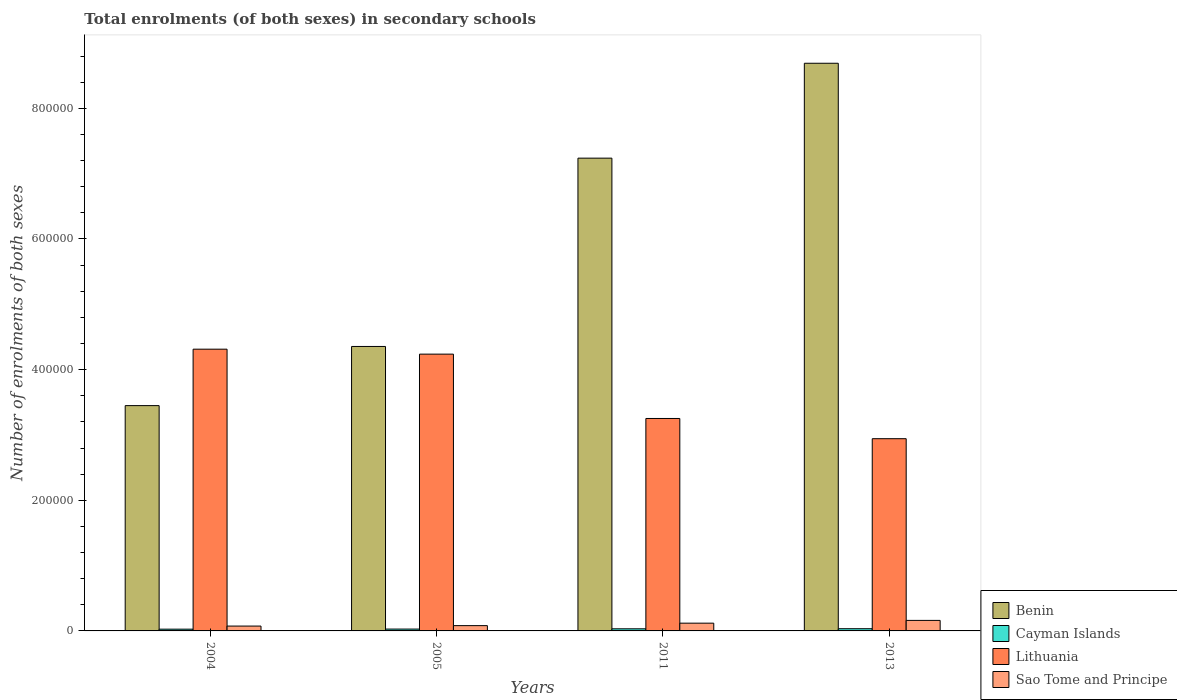Are the number of bars on each tick of the X-axis equal?
Provide a succinct answer. Yes. How many bars are there on the 4th tick from the left?
Ensure brevity in your answer.  4. In how many cases, is the number of bars for a given year not equal to the number of legend labels?
Your answer should be very brief. 0. What is the number of enrolments in secondary schools in Lithuania in 2013?
Ensure brevity in your answer.  2.94e+05. Across all years, what is the maximum number of enrolments in secondary schools in Benin?
Offer a very short reply. 8.69e+05. Across all years, what is the minimum number of enrolments in secondary schools in Cayman Islands?
Ensure brevity in your answer.  2701. In which year was the number of enrolments in secondary schools in Benin maximum?
Your answer should be very brief. 2013. What is the total number of enrolments in secondary schools in Cayman Islands in the graph?
Your answer should be very brief. 1.22e+04. What is the difference between the number of enrolments in secondary schools in Lithuania in 2011 and that in 2013?
Keep it short and to the point. 3.09e+04. What is the difference between the number of enrolments in secondary schools in Cayman Islands in 2011 and the number of enrolments in secondary schools in Lithuania in 2004?
Ensure brevity in your answer.  -4.28e+05. What is the average number of enrolments in secondary schools in Lithuania per year?
Make the answer very short. 3.69e+05. In the year 2013, what is the difference between the number of enrolments in secondary schools in Sao Tome and Principe and number of enrolments in secondary schools in Benin?
Your answer should be very brief. -8.53e+05. In how many years, is the number of enrolments in secondary schools in Benin greater than 40000?
Keep it short and to the point. 4. What is the ratio of the number of enrolments in secondary schools in Lithuania in 2011 to that in 2013?
Provide a short and direct response. 1.11. Is the number of enrolments in secondary schools in Cayman Islands in 2011 less than that in 2013?
Your answer should be compact. Yes. Is the difference between the number of enrolments in secondary schools in Sao Tome and Principe in 2004 and 2013 greater than the difference between the number of enrolments in secondary schools in Benin in 2004 and 2013?
Offer a very short reply. Yes. What is the difference between the highest and the second highest number of enrolments in secondary schools in Cayman Islands?
Give a very brief answer. 141. What is the difference between the highest and the lowest number of enrolments in secondary schools in Lithuania?
Keep it short and to the point. 1.37e+05. In how many years, is the number of enrolments in secondary schools in Sao Tome and Principe greater than the average number of enrolments in secondary schools in Sao Tome and Principe taken over all years?
Your answer should be compact. 2. Is the sum of the number of enrolments in secondary schools in Lithuania in 2004 and 2013 greater than the maximum number of enrolments in secondary schools in Cayman Islands across all years?
Make the answer very short. Yes. Is it the case that in every year, the sum of the number of enrolments in secondary schools in Benin and number of enrolments in secondary schools in Sao Tome and Principe is greater than the sum of number of enrolments in secondary schools in Cayman Islands and number of enrolments in secondary schools in Lithuania?
Your answer should be very brief. No. What does the 4th bar from the left in 2013 represents?
Offer a terse response. Sao Tome and Principe. What does the 4th bar from the right in 2011 represents?
Give a very brief answer. Benin. How many bars are there?
Give a very brief answer. 16. How many years are there in the graph?
Your answer should be compact. 4. How many legend labels are there?
Your answer should be very brief. 4. How are the legend labels stacked?
Provide a short and direct response. Vertical. What is the title of the graph?
Your answer should be compact. Total enrolments (of both sexes) in secondary schools. What is the label or title of the X-axis?
Keep it short and to the point. Years. What is the label or title of the Y-axis?
Offer a terse response. Number of enrolments of both sexes. What is the Number of enrolments of both sexes of Benin in 2004?
Offer a very short reply. 3.45e+05. What is the Number of enrolments of both sexes of Cayman Islands in 2004?
Give a very brief answer. 2701. What is the Number of enrolments of both sexes of Lithuania in 2004?
Give a very brief answer. 4.31e+05. What is the Number of enrolments of both sexes in Sao Tome and Principe in 2004?
Give a very brief answer. 7423. What is the Number of enrolments of both sexes of Benin in 2005?
Provide a short and direct response. 4.35e+05. What is the Number of enrolments of both sexes of Cayman Islands in 2005?
Your response must be concise. 2824. What is the Number of enrolments of both sexes of Lithuania in 2005?
Your response must be concise. 4.24e+05. What is the Number of enrolments of both sexes of Sao Tome and Principe in 2005?
Give a very brief answer. 8091. What is the Number of enrolments of both sexes in Benin in 2011?
Your answer should be very brief. 7.24e+05. What is the Number of enrolments of both sexes of Cayman Islands in 2011?
Your answer should be compact. 3246. What is the Number of enrolments of both sexes in Lithuania in 2011?
Give a very brief answer. 3.25e+05. What is the Number of enrolments of both sexes in Sao Tome and Principe in 2011?
Give a very brief answer. 1.19e+04. What is the Number of enrolments of both sexes of Benin in 2013?
Give a very brief answer. 8.69e+05. What is the Number of enrolments of both sexes of Cayman Islands in 2013?
Offer a terse response. 3387. What is the Number of enrolments of both sexes in Lithuania in 2013?
Your response must be concise. 2.94e+05. What is the Number of enrolments of both sexes in Sao Tome and Principe in 2013?
Give a very brief answer. 1.61e+04. Across all years, what is the maximum Number of enrolments of both sexes of Benin?
Keep it short and to the point. 8.69e+05. Across all years, what is the maximum Number of enrolments of both sexes of Cayman Islands?
Give a very brief answer. 3387. Across all years, what is the maximum Number of enrolments of both sexes of Lithuania?
Offer a very short reply. 4.31e+05. Across all years, what is the maximum Number of enrolments of both sexes of Sao Tome and Principe?
Your answer should be very brief. 1.61e+04. Across all years, what is the minimum Number of enrolments of both sexes in Benin?
Your answer should be compact. 3.45e+05. Across all years, what is the minimum Number of enrolments of both sexes in Cayman Islands?
Make the answer very short. 2701. Across all years, what is the minimum Number of enrolments of both sexes of Lithuania?
Your answer should be very brief. 2.94e+05. Across all years, what is the minimum Number of enrolments of both sexes in Sao Tome and Principe?
Provide a short and direct response. 7423. What is the total Number of enrolments of both sexes of Benin in the graph?
Provide a succinct answer. 2.37e+06. What is the total Number of enrolments of both sexes in Cayman Islands in the graph?
Offer a terse response. 1.22e+04. What is the total Number of enrolments of both sexes in Lithuania in the graph?
Your answer should be very brief. 1.47e+06. What is the total Number of enrolments of both sexes in Sao Tome and Principe in the graph?
Your response must be concise. 4.35e+04. What is the difference between the Number of enrolments of both sexes in Benin in 2004 and that in 2005?
Your response must be concise. -9.06e+04. What is the difference between the Number of enrolments of both sexes in Cayman Islands in 2004 and that in 2005?
Keep it short and to the point. -123. What is the difference between the Number of enrolments of both sexes of Lithuania in 2004 and that in 2005?
Make the answer very short. 7597. What is the difference between the Number of enrolments of both sexes in Sao Tome and Principe in 2004 and that in 2005?
Make the answer very short. -668. What is the difference between the Number of enrolments of both sexes in Benin in 2004 and that in 2011?
Your response must be concise. -3.79e+05. What is the difference between the Number of enrolments of both sexes of Cayman Islands in 2004 and that in 2011?
Your answer should be compact. -545. What is the difference between the Number of enrolments of both sexes of Lithuania in 2004 and that in 2011?
Your response must be concise. 1.06e+05. What is the difference between the Number of enrolments of both sexes in Sao Tome and Principe in 2004 and that in 2011?
Provide a succinct answer. -4461. What is the difference between the Number of enrolments of both sexes in Benin in 2004 and that in 2013?
Keep it short and to the point. -5.24e+05. What is the difference between the Number of enrolments of both sexes in Cayman Islands in 2004 and that in 2013?
Provide a succinct answer. -686. What is the difference between the Number of enrolments of both sexes in Lithuania in 2004 and that in 2013?
Keep it short and to the point. 1.37e+05. What is the difference between the Number of enrolments of both sexes of Sao Tome and Principe in 2004 and that in 2013?
Offer a very short reply. -8695. What is the difference between the Number of enrolments of both sexes in Benin in 2005 and that in 2011?
Your response must be concise. -2.88e+05. What is the difference between the Number of enrolments of both sexes of Cayman Islands in 2005 and that in 2011?
Provide a succinct answer. -422. What is the difference between the Number of enrolments of both sexes of Lithuania in 2005 and that in 2011?
Provide a short and direct response. 9.85e+04. What is the difference between the Number of enrolments of both sexes of Sao Tome and Principe in 2005 and that in 2011?
Make the answer very short. -3793. What is the difference between the Number of enrolments of both sexes in Benin in 2005 and that in 2013?
Ensure brevity in your answer.  -4.34e+05. What is the difference between the Number of enrolments of both sexes of Cayman Islands in 2005 and that in 2013?
Offer a very short reply. -563. What is the difference between the Number of enrolments of both sexes of Lithuania in 2005 and that in 2013?
Ensure brevity in your answer.  1.29e+05. What is the difference between the Number of enrolments of both sexes in Sao Tome and Principe in 2005 and that in 2013?
Your answer should be compact. -8027. What is the difference between the Number of enrolments of both sexes of Benin in 2011 and that in 2013?
Keep it short and to the point. -1.45e+05. What is the difference between the Number of enrolments of both sexes of Cayman Islands in 2011 and that in 2013?
Give a very brief answer. -141. What is the difference between the Number of enrolments of both sexes of Lithuania in 2011 and that in 2013?
Provide a succinct answer. 3.09e+04. What is the difference between the Number of enrolments of both sexes of Sao Tome and Principe in 2011 and that in 2013?
Give a very brief answer. -4234. What is the difference between the Number of enrolments of both sexes in Benin in 2004 and the Number of enrolments of both sexes in Cayman Islands in 2005?
Your answer should be very brief. 3.42e+05. What is the difference between the Number of enrolments of both sexes of Benin in 2004 and the Number of enrolments of both sexes of Lithuania in 2005?
Your response must be concise. -7.88e+04. What is the difference between the Number of enrolments of both sexes in Benin in 2004 and the Number of enrolments of both sexes in Sao Tome and Principe in 2005?
Make the answer very short. 3.37e+05. What is the difference between the Number of enrolments of both sexes of Cayman Islands in 2004 and the Number of enrolments of both sexes of Lithuania in 2005?
Provide a short and direct response. -4.21e+05. What is the difference between the Number of enrolments of both sexes of Cayman Islands in 2004 and the Number of enrolments of both sexes of Sao Tome and Principe in 2005?
Your response must be concise. -5390. What is the difference between the Number of enrolments of both sexes of Lithuania in 2004 and the Number of enrolments of both sexes of Sao Tome and Principe in 2005?
Your answer should be very brief. 4.23e+05. What is the difference between the Number of enrolments of both sexes in Benin in 2004 and the Number of enrolments of both sexes in Cayman Islands in 2011?
Keep it short and to the point. 3.42e+05. What is the difference between the Number of enrolments of both sexes in Benin in 2004 and the Number of enrolments of both sexes in Lithuania in 2011?
Provide a succinct answer. 1.97e+04. What is the difference between the Number of enrolments of both sexes of Benin in 2004 and the Number of enrolments of both sexes of Sao Tome and Principe in 2011?
Ensure brevity in your answer.  3.33e+05. What is the difference between the Number of enrolments of both sexes in Cayman Islands in 2004 and the Number of enrolments of both sexes in Lithuania in 2011?
Provide a succinct answer. -3.23e+05. What is the difference between the Number of enrolments of both sexes in Cayman Islands in 2004 and the Number of enrolments of both sexes in Sao Tome and Principe in 2011?
Provide a short and direct response. -9183. What is the difference between the Number of enrolments of both sexes in Lithuania in 2004 and the Number of enrolments of both sexes in Sao Tome and Principe in 2011?
Your answer should be very brief. 4.19e+05. What is the difference between the Number of enrolments of both sexes in Benin in 2004 and the Number of enrolments of both sexes in Cayman Islands in 2013?
Provide a short and direct response. 3.42e+05. What is the difference between the Number of enrolments of both sexes of Benin in 2004 and the Number of enrolments of both sexes of Lithuania in 2013?
Make the answer very short. 5.06e+04. What is the difference between the Number of enrolments of both sexes of Benin in 2004 and the Number of enrolments of both sexes of Sao Tome and Principe in 2013?
Your answer should be very brief. 3.29e+05. What is the difference between the Number of enrolments of both sexes in Cayman Islands in 2004 and the Number of enrolments of both sexes in Lithuania in 2013?
Your answer should be compact. -2.92e+05. What is the difference between the Number of enrolments of both sexes in Cayman Islands in 2004 and the Number of enrolments of both sexes in Sao Tome and Principe in 2013?
Offer a terse response. -1.34e+04. What is the difference between the Number of enrolments of both sexes in Lithuania in 2004 and the Number of enrolments of both sexes in Sao Tome and Principe in 2013?
Provide a succinct answer. 4.15e+05. What is the difference between the Number of enrolments of both sexes in Benin in 2005 and the Number of enrolments of both sexes in Cayman Islands in 2011?
Ensure brevity in your answer.  4.32e+05. What is the difference between the Number of enrolments of both sexes in Benin in 2005 and the Number of enrolments of both sexes in Lithuania in 2011?
Make the answer very short. 1.10e+05. What is the difference between the Number of enrolments of both sexes in Benin in 2005 and the Number of enrolments of both sexes in Sao Tome and Principe in 2011?
Your answer should be compact. 4.24e+05. What is the difference between the Number of enrolments of both sexes in Cayman Islands in 2005 and the Number of enrolments of both sexes in Lithuania in 2011?
Keep it short and to the point. -3.22e+05. What is the difference between the Number of enrolments of both sexes in Cayman Islands in 2005 and the Number of enrolments of both sexes in Sao Tome and Principe in 2011?
Your answer should be very brief. -9060. What is the difference between the Number of enrolments of both sexes in Lithuania in 2005 and the Number of enrolments of both sexes in Sao Tome and Principe in 2011?
Give a very brief answer. 4.12e+05. What is the difference between the Number of enrolments of both sexes of Benin in 2005 and the Number of enrolments of both sexes of Cayman Islands in 2013?
Keep it short and to the point. 4.32e+05. What is the difference between the Number of enrolments of both sexes of Benin in 2005 and the Number of enrolments of both sexes of Lithuania in 2013?
Your response must be concise. 1.41e+05. What is the difference between the Number of enrolments of both sexes of Benin in 2005 and the Number of enrolments of both sexes of Sao Tome and Principe in 2013?
Give a very brief answer. 4.19e+05. What is the difference between the Number of enrolments of both sexes of Cayman Islands in 2005 and the Number of enrolments of both sexes of Lithuania in 2013?
Your answer should be very brief. -2.91e+05. What is the difference between the Number of enrolments of both sexes in Cayman Islands in 2005 and the Number of enrolments of both sexes in Sao Tome and Principe in 2013?
Provide a short and direct response. -1.33e+04. What is the difference between the Number of enrolments of both sexes in Lithuania in 2005 and the Number of enrolments of both sexes in Sao Tome and Principe in 2013?
Offer a terse response. 4.08e+05. What is the difference between the Number of enrolments of both sexes in Benin in 2011 and the Number of enrolments of both sexes in Cayman Islands in 2013?
Keep it short and to the point. 7.20e+05. What is the difference between the Number of enrolments of both sexes in Benin in 2011 and the Number of enrolments of both sexes in Lithuania in 2013?
Your response must be concise. 4.29e+05. What is the difference between the Number of enrolments of both sexes in Benin in 2011 and the Number of enrolments of both sexes in Sao Tome and Principe in 2013?
Your response must be concise. 7.08e+05. What is the difference between the Number of enrolments of both sexes in Cayman Islands in 2011 and the Number of enrolments of both sexes in Lithuania in 2013?
Offer a very short reply. -2.91e+05. What is the difference between the Number of enrolments of both sexes in Cayman Islands in 2011 and the Number of enrolments of both sexes in Sao Tome and Principe in 2013?
Your answer should be very brief. -1.29e+04. What is the difference between the Number of enrolments of both sexes in Lithuania in 2011 and the Number of enrolments of both sexes in Sao Tome and Principe in 2013?
Make the answer very short. 3.09e+05. What is the average Number of enrolments of both sexes in Benin per year?
Provide a short and direct response. 5.93e+05. What is the average Number of enrolments of both sexes in Cayman Islands per year?
Ensure brevity in your answer.  3039.5. What is the average Number of enrolments of both sexes of Lithuania per year?
Offer a very short reply. 3.69e+05. What is the average Number of enrolments of both sexes in Sao Tome and Principe per year?
Your answer should be compact. 1.09e+04. In the year 2004, what is the difference between the Number of enrolments of both sexes in Benin and Number of enrolments of both sexes in Cayman Islands?
Give a very brief answer. 3.42e+05. In the year 2004, what is the difference between the Number of enrolments of both sexes of Benin and Number of enrolments of both sexes of Lithuania?
Offer a very short reply. -8.64e+04. In the year 2004, what is the difference between the Number of enrolments of both sexes in Benin and Number of enrolments of both sexes in Sao Tome and Principe?
Make the answer very short. 3.37e+05. In the year 2004, what is the difference between the Number of enrolments of both sexes of Cayman Islands and Number of enrolments of both sexes of Lithuania?
Give a very brief answer. -4.29e+05. In the year 2004, what is the difference between the Number of enrolments of both sexes of Cayman Islands and Number of enrolments of both sexes of Sao Tome and Principe?
Give a very brief answer. -4722. In the year 2004, what is the difference between the Number of enrolments of both sexes of Lithuania and Number of enrolments of both sexes of Sao Tome and Principe?
Make the answer very short. 4.24e+05. In the year 2005, what is the difference between the Number of enrolments of both sexes in Benin and Number of enrolments of both sexes in Cayman Islands?
Offer a very short reply. 4.33e+05. In the year 2005, what is the difference between the Number of enrolments of both sexes of Benin and Number of enrolments of both sexes of Lithuania?
Offer a very short reply. 1.17e+04. In the year 2005, what is the difference between the Number of enrolments of both sexes in Benin and Number of enrolments of both sexes in Sao Tome and Principe?
Your answer should be very brief. 4.27e+05. In the year 2005, what is the difference between the Number of enrolments of both sexes of Cayman Islands and Number of enrolments of both sexes of Lithuania?
Provide a succinct answer. -4.21e+05. In the year 2005, what is the difference between the Number of enrolments of both sexes in Cayman Islands and Number of enrolments of both sexes in Sao Tome and Principe?
Provide a short and direct response. -5267. In the year 2005, what is the difference between the Number of enrolments of both sexes in Lithuania and Number of enrolments of both sexes in Sao Tome and Principe?
Your answer should be very brief. 4.16e+05. In the year 2011, what is the difference between the Number of enrolments of both sexes in Benin and Number of enrolments of both sexes in Cayman Islands?
Your response must be concise. 7.20e+05. In the year 2011, what is the difference between the Number of enrolments of both sexes of Benin and Number of enrolments of both sexes of Lithuania?
Provide a succinct answer. 3.99e+05. In the year 2011, what is the difference between the Number of enrolments of both sexes in Benin and Number of enrolments of both sexes in Sao Tome and Principe?
Offer a terse response. 7.12e+05. In the year 2011, what is the difference between the Number of enrolments of both sexes in Cayman Islands and Number of enrolments of both sexes in Lithuania?
Ensure brevity in your answer.  -3.22e+05. In the year 2011, what is the difference between the Number of enrolments of both sexes in Cayman Islands and Number of enrolments of both sexes in Sao Tome and Principe?
Ensure brevity in your answer.  -8638. In the year 2011, what is the difference between the Number of enrolments of both sexes in Lithuania and Number of enrolments of both sexes in Sao Tome and Principe?
Provide a succinct answer. 3.13e+05. In the year 2013, what is the difference between the Number of enrolments of both sexes of Benin and Number of enrolments of both sexes of Cayman Islands?
Your answer should be very brief. 8.66e+05. In the year 2013, what is the difference between the Number of enrolments of both sexes of Benin and Number of enrolments of both sexes of Lithuania?
Offer a terse response. 5.75e+05. In the year 2013, what is the difference between the Number of enrolments of both sexes in Benin and Number of enrolments of both sexes in Sao Tome and Principe?
Your response must be concise. 8.53e+05. In the year 2013, what is the difference between the Number of enrolments of both sexes of Cayman Islands and Number of enrolments of both sexes of Lithuania?
Give a very brief answer. -2.91e+05. In the year 2013, what is the difference between the Number of enrolments of both sexes in Cayman Islands and Number of enrolments of both sexes in Sao Tome and Principe?
Provide a succinct answer. -1.27e+04. In the year 2013, what is the difference between the Number of enrolments of both sexes of Lithuania and Number of enrolments of both sexes of Sao Tome and Principe?
Provide a short and direct response. 2.78e+05. What is the ratio of the Number of enrolments of both sexes of Benin in 2004 to that in 2005?
Your response must be concise. 0.79. What is the ratio of the Number of enrolments of both sexes in Cayman Islands in 2004 to that in 2005?
Make the answer very short. 0.96. What is the ratio of the Number of enrolments of both sexes in Lithuania in 2004 to that in 2005?
Your answer should be compact. 1.02. What is the ratio of the Number of enrolments of both sexes in Sao Tome and Principe in 2004 to that in 2005?
Provide a short and direct response. 0.92. What is the ratio of the Number of enrolments of both sexes of Benin in 2004 to that in 2011?
Keep it short and to the point. 0.48. What is the ratio of the Number of enrolments of both sexes in Cayman Islands in 2004 to that in 2011?
Keep it short and to the point. 0.83. What is the ratio of the Number of enrolments of both sexes in Lithuania in 2004 to that in 2011?
Your response must be concise. 1.33. What is the ratio of the Number of enrolments of both sexes of Sao Tome and Principe in 2004 to that in 2011?
Ensure brevity in your answer.  0.62. What is the ratio of the Number of enrolments of both sexes of Benin in 2004 to that in 2013?
Give a very brief answer. 0.4. What is the ratio of the Number of enrolments of both sexes of Cayman Islands in 2004 to that in 2013?
Your response must be concise. 0.8. What is the ratio of the Number of enrolments of both sexes in Lithuania in 2004 to that in 2013?
Ensure brevity in your answer.  1.47. What is the ratio of the Number of enrolments of both sexes of Sao Tome and Principe in 2004 to that in 2013?
Provide a succinct answer. 0.46. What is the ratio of the Number of enrolments of both sexes of Benin in 2005 to that in 2011?
Offer a terse response. 0.6. What is the ratio of the Number of enrolments of both sexes in Cayman Islands in 2005 to that in 2011?
Provide a short and direct response. 0.87. What is the ratio of the Number of enrolments of both sexes of Lithuania in 2005 to that in 2011?
Offer a very short reply. 1.3. What is the ratio of the Number of enrolments of both sexes in Sao Tome and Principe in 2005 to that in 2011?
Your answer should be compact. 0.68. What is the ratio of the Number of enrolments of both sexes in Benin in 2005 to that in 2013?
Ensure brevity in your answer.  0.5. What is the ratio of the Number of enrolments of both sexes in Cayman Islands in 2005 to that in 2013?
Your answer should be very brief. 0.83. What is the ratio of the Number of enrolments of both sexes of Lithuania in 2005 to that in 2013?
Offer a terse response. 1.44. What is the ratio of the Number of enrolments of both sexes in Sao Tome and Principe in 2005 to that in 2013?
Keep it short and to the point. 0.5. What is the ratio of the Number of enrolments of both sexes of Benin in 2011 to that in 2013?
Give a very brief answer. 0.83. What is the ratio of the Number of enrolments of both sexes of Cayman Islands in 2011 to that in 2013?
Provide a short and direct response. 0.96. What is the ratio of the Number of enrolments of both sexes in Lithuania in 2011 to that in 2013?
Your answer should be compact. 1.11. What is the ratio of the Number of enrolments of both sexes in Sao Tome and Principe in 2011 to that in 2013?
Your response must be concise. 0.74. What is the difference between the highest and the second highest Number of enrolments of both sexes in Benin?
Offer a terse response. 1.45e+05. What is the difference between the highest and the second highest Number of enrolments of both sexes in Cayman Islands?
Provide a succinct answer. 141. What is the difference between the highest and the second highest Number of enrolments of both sexes in Lithuania?
Keep it short and to the point. 7597. What is the difference between the highest and the second highest Number of enrolments of both sexes of Sao Tome and Principe?
Give a very brief answer. 4234. What is the difference between the highest and the lowest Number of enrolments of both sexes in Benin?
Offer a very short reply. 5.24e+05. What is the difference between the highest and the lowest Number of enrolments of both sexes of Cayman Islands?
Offer a very short reply. 686. What is the difference between the highest and the lowest Number of enrolments of both sexes of Lithuania?
Keep it short and to the point. 1.37e+05. What is the difference between the highest and the lowest Number of enrolments of both sexes in Sao Tome and Principe?
Keep it short and to the point. 8695. 